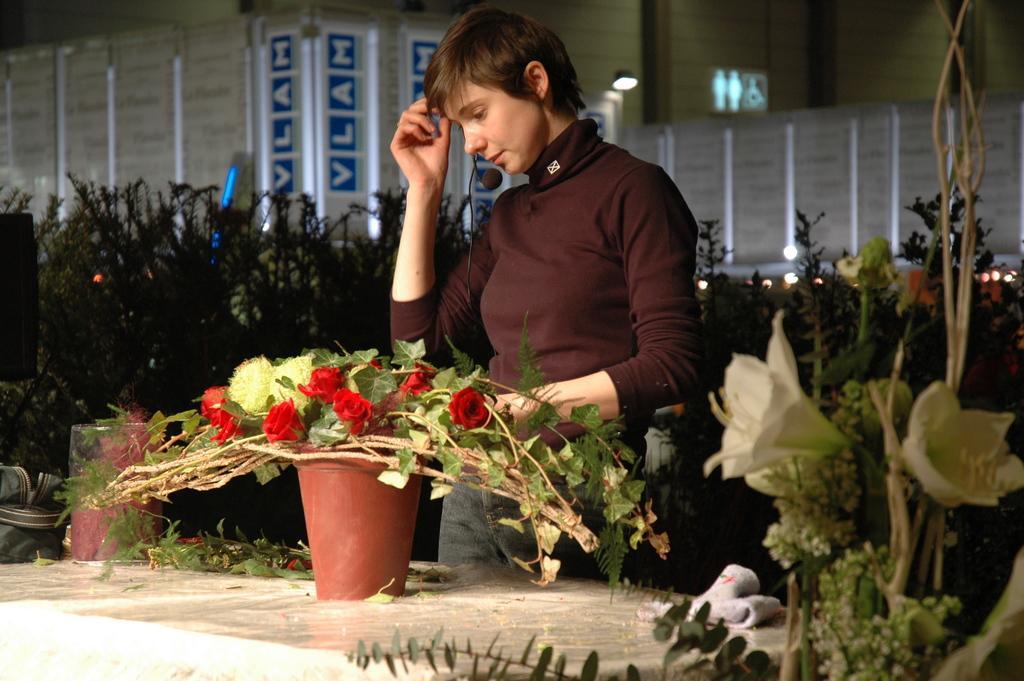In one or two sentences, can you explain what this image depicts? There is a woman standing,in front of this woman we can see flowers,pot and objects on the surface. Background we can see plants,wall and lights. 